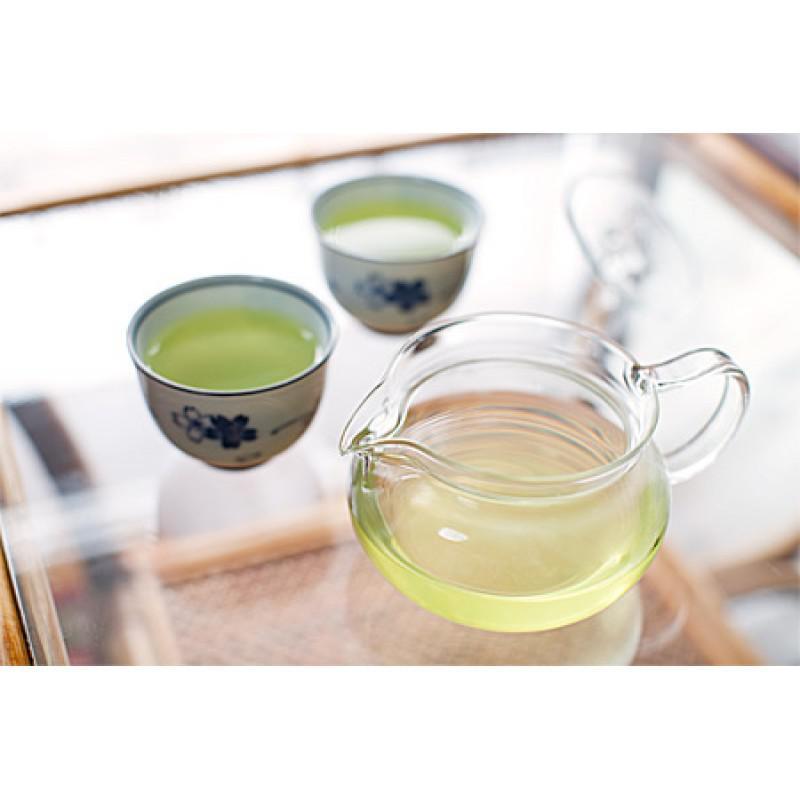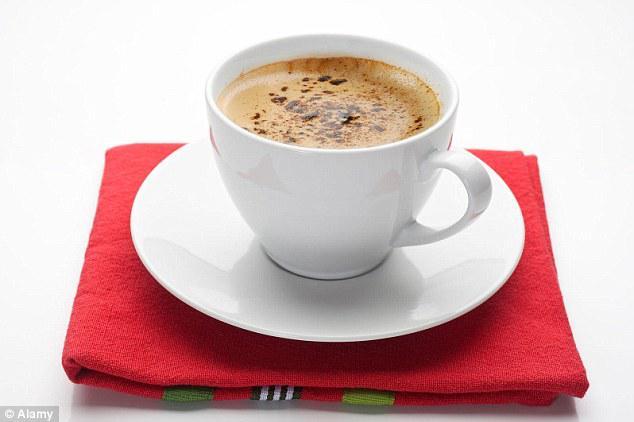The first image is the image on the left, the second image is the image on the right. For the images displayed, is the sentence "At least one white cup sits in a white saucer." factually correct? Answer yes or no. Yes. The first image is the image on the left, the second image is the image on the right. Assess this claim about the two images: "Each image shows two side-by-side cups.". Correct or not? Answer yes or no. No. 